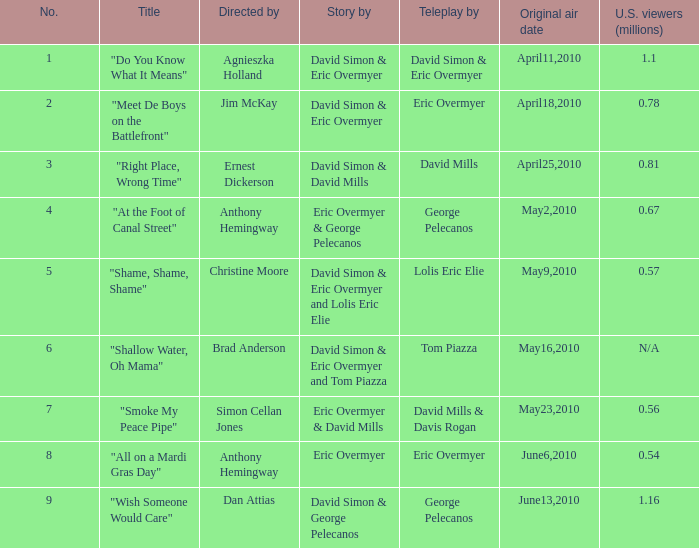Identify the largest number. 9.0. 